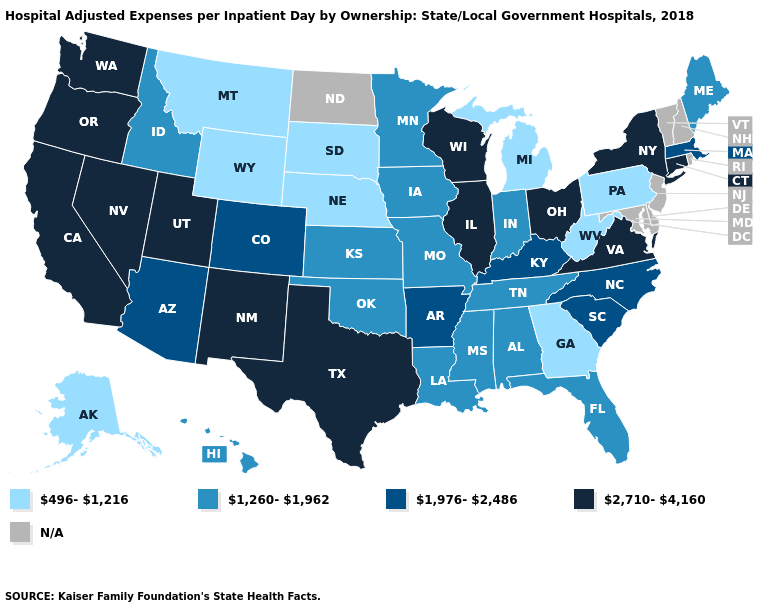What is the highest value in the USA?
Quick response, please. 2,710-4,160. Which states have the lowest value in the Northeast?
Answer briefly. Pennsylvania. What is the highest value in the South ?
Short answer required. 2,710-4,160. Name the states that have a value in the range 2,710-4,160?
Write a very short answer. California, Connecticut, Illinois, Nevada, New Mexico, New York, Ohio, Oregon, Texas, Utah, Virginia, Washington, Wisconsin. What is the highest value in the USA?
Answer briefly. 2,710-4,160. Which states hav the highest value in the MidWest?
Write a very short answer. Illinois, Ohio, Wisconsin. What is the value of Maine?
Short answer required. 1,260-1,962. How many symbols are there in the legend?
Quick response, please. 5. How many symbols are there in the legend?
Concise answer only. 5. Name the states that have a value in the range 496-1,216?
Concise answer only. Alaska, Georgia, Michigan, Montana, Nebraska, Pennsylvania, South Dakota, West Virginia, Wyoming. What is the highest value in the MidWest ?
Keep it brief. 2,710-4,160. Does Colorado have the highest value in the USA?
Short answer required. No. Does the first symbol in the legend represent the smallest category?
Answer briefly. Yes. Name the states that have a value in the range 1,260-1,962?
Be succinct. Alabama, Florida, Hawaii, Idaho, Indiana, Iowa, Kansas, Louisiana, Maine, Minnesota, Mississippi, Missouri, Oklahoma, Tennessee. 